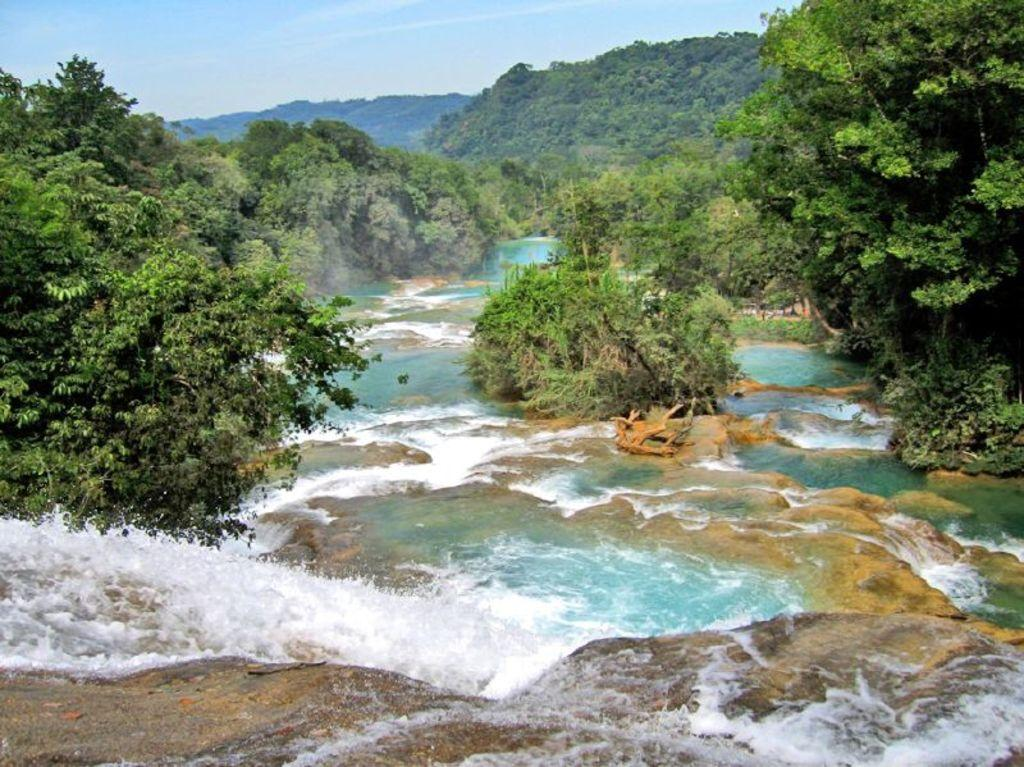What natural feature is the main subject of the image? There is a waterfall in the image. What other elements can be seen in the image? There are rocks in the image. What can be seen in the background of the image? There are trees, mountains, and the sky visible in the background of the image. What type of advice can be seen written on the rocks in the image? There is no advice written on the rocks in the image; the rocks are simply part of the natural landscape. 